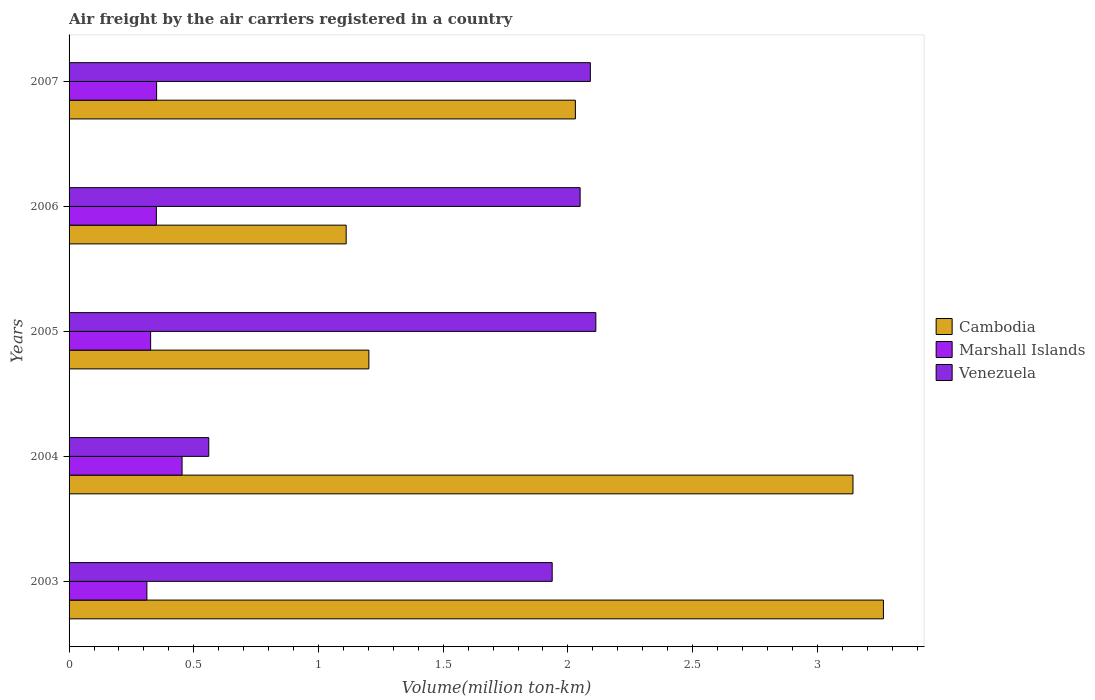How many different coloured bars are there?
Make the answer very short. 3. How many groups of bars are there?
Ensure brevity in your answer.  5. How many bars are there on the 2nd tick from the top?
Give a very brief answer. 3. What is the label of the 3rd group of bars from the top?
Your answer should be very brief. 2005. In how many cases, is the number of bars for a given year not equal to the number of legend labels?
Provide a short and direct response. 0. What is the volume of the air carriers in Marshall Islands in 2003?
Provide a succinct answer. 0.31. Across all years, what is the maximum volume of the air carriers in Cambodia?
Your response must be concise. 3.27. Across all years, what is the minimum volume of the air carriers in Marshall Islands?
Offer a terse response. 0.31. In which year was the volume of the air carriers in Venezuela maximum?
Ensure brevity in your answer.  2005. What is the total volume of the air carriers in Venezuela in the graph?
Offer a terse response. 8.75. What is the difference between the volume of the air carriers in Venezuela in 2003 and that in 2004?
Your response must be concise. 1.38. What is the difference between the volume of the air carriers in Marshall Islands in 2004 and the volume of the air carriers in Venezuela in 2007?
Provide a short and direct response. -1.64. What is the average volume of the air carriers in Venezuela per year?
Give a very brief answer. 1.75. In the year 2006, what is the difference between the volume of the air carriers in Cambodia and volume of the air carriers in Marshall Islands?
Provide a succinct answer. 0.76. What is the ratio of the volume of the air carriers in Marshall Islands in 2003 to that in 2006?
Keep it short and to the point. 0.89. Is the difference between the volume of the air carriers in Cambodia in 2004 and 2007 greater than the difference between the volume of the air carriers in Marshall Islands in 2004 and 2007?
Your answer should be compact. Yes. What is the difference between the highest and the second highest volume of the air carriers in Marshall Islands?
Your response must be concise. 0.1. What is the difference between the highest and the lowest volume of the air carriers in Marshall Islands?
Your answer should be very brief. 0.14. In how many years, is the volume of the air carriers in Venezuela greater than the average volume of the air carriers in Venezuela taken over all years?
Offer a very short reply. 4. What does the 3rd bar from the top in 2004 represents?
Provide a short and direct response. Cambodia. What does the 3rd bar from the bottom in 2007 represents?
Give a very brief answer. Venezuela. Are all the bars in the graph horizontal?
Your answer should be compact. Yes. How many years are there in the graph?
Your answer should be very brief. 5. Does the graph contain any zero values?
Make the answer very short. No. Does the graph contain grids?
Keep it short and to the point. No. Where does the legend appear in the graph?
Keep it short and to the point. Center right. How are the legend labels stacked?
Keep it short and to the point. Vertical. What is the title of the graph?
Offer a terse response. Air freight by the air carriers registered in a country. What is the label or title of the X-axis?
Your answer should be very brief. Volume(million ton-km). What is the Volume(million ton-km) of Cambodia in 2003?
Offer a very short reply. 3.27. What is the Volume(million ton-km) of Marshall Islands in 2003?
Provide a succinct answer. 0.31. What is the Volume(million ton-km) in Venezuela in 2003?
Provide a succinct answer. 1.94. What is the Volume(million ton-km) of Cambodia in 2004?
Provide a short and direct response. 3.14. What is the Volume(million ton-km) in Marshall Islands in 2004?
Ensure brevity in your answer.  0.45. What is the Volume(million ton-km) in Venezuela in 2004?
Provide a short and direct response. 0.56. What is the Volume(million ton-km) of Cambodia in 2005?
Offer a very short reply. 1.2. What is the Volume(million ton-km) in Marshall Islands in 2005?
Offer a terse response. 0.33. What is the Volume(million ton-km) of Venezuela in 2005?
Your answer should be compact. 2.11. What is the Volume(million ton-km) of Cambodia in 2006?
Provide a succinct answer. 1.11. What is the Volume(million ton-km) of Venezuela in 2006?
Your response must be concise. 2.05. What is the Volume(million ton-km) of Cambodia in 2007?
Offer a terse response. 2.03. What is the Volume(million ton-km) in Marshall Islands in 2007?
Ensure brevity in your answer.  0.35. What is the Volume(million ton-km) in Venezuela in 2007?
Offer a terse response. 2.09. Across all years, what is the maximum Volume(million ton-km) in Cambodia?
Provide a short and direct response. 3.27. Across all years, what is the maximum Volume(million ton-km) in Marshall Islands?
Your answer should be very brief. 0.45. Across all years, what is the maximum Volume(million ton-km) in Venezuela?
Your answer should be very brief. 2.11. Across all years, what is the minimum Volume(million ton-km) in Cambodia?
Keep it short and to the point. 1.11. Across all years, what is the minimum Volume(million ton-km) in Marshall Islands?
Provide a short and direct response. 0.31. Across all years, what is the minimum Volume(million ton-km) in Venezuela?
Offer a very short reply. 0.56. What is the total Volume(million ton-km) of Cambodia in the graph?
Offer a very short reply. 10.75. What is the total Volume(million ton-km) of Marshall Islands in the graph?
Provide a short and direct response. 1.79. What is the total Volume(million ton-km) in Venezuela in the graph?
Provide a short and direct response. 8.75. What is the difference between the Volume(million ton-km) in Cambodia in 2003 and that in 2004?
Your response must be concise. 0.12. What is the difference between the Volume(million ton-km) of Marshall Islands in 2003 and that in 2004?
Give a very brief answer. -0.14. What is the difference between the Volume(million ton-km) of Venezuela in 2003 and that in 2004?
Ensure brevity in your answer.  1.38. What is the difference between the Volume(million ton-km) of Cambodia in 2003 and that in 2005?
Offer a very short reply. 2.06. What is the difference between the Volume(million ton-km) of Marshall Islands in 2003 and that in 2005?
Offer a terse response. -0.01. What is the difference between the Volume(million ton-km) of Venezuela in 2003 and that in 2005?
Your answer should be compact. -0.17. What is the difference between the Volume(million ton-km) in Cambodia in 2003 and that in 2006?
Provide a succinct answer. 2.15. What is the difference between the Volume(million ton-km) in Marshall Islands in 2003 and that in 2006?
Provide a short and direct response. -0.04. What is the difference between the Volume(million ton-km) in Venezuela in 2003 and that in 2006?
Your response must be concise. -0.11. What is the difference between the Volume(million ton-km) of Cambodia in 2003 and that in 2007?
Offer a terse response. 1.24. What is the difference between the Volume(million ton-km) of Marshall Islands in 2003 and that in 2007?
Make the answer very short. -0.04. What is the difference between the Volume(million ton-km) of Venezuela in 2003 and that in 2007?
Make the answer very short. -0.15. What is the difference between the Volume(million ton-km) in Cambodia in 2004 and that in 2005?
Ensure brevity in your answer.  1.94. What is the difference between the Volume(million ton-km) of Marshall Islands in 2004 and that in 2005?
Offer a terse response. 0.13. What is the difference between the Volume(million ton-km) of Venezuela in 2004 and that in 2005?
Your answer should be very brief. -1.55. What is the difference between the Volume(million ton-km) of Cambodia in 2004 and that in 2006?
Keep it short and to the point. 2.03. What is the difference between the Volume(million ton-km) of Marshall Islands in 2004 and that in 2006?
Provide a succinct answer. 0.1. What is the difference between the Volume(million ton-km) of Venezuela in 2004 and that in 2006?
Keep it short and to the point. -1.49. What is the difference between the Volume(million ton-km) in Cambodia in 2004 and that in 2007?
Your answer should be very brief. 1.11. What is the difference between the Volume(million ton-km) in Marshall Islands in 2004 and that in 2007?
Offer a terse response. 0.1. What is the difference between the Volume(million ton-km) in Venezuela in 2004 and that in 2007?
Ensure brevity in your answer.  -1.53. What is the difference between the Volume(million ton-km) of Cambodia in 2005 and that in 2006?
Ensure brevity in your answer.  0.09. What is the difference between the Volume(million ton-km) in Marshall Islands in 2005 and that in 2006?
Ensure brevity in your answer.  -0.02. What is the difference between the Volume(million ton-km) of Venezuela in 2005 and that in 2006?
Offer a terse response. 0.06. What is the difference between the Volume(million ton-km) of Cambodia in 2005 and that in 2007?
Your response must be concise. -0.83. What is the difference between the Volume(million ton-km) in Marshall Islands in 2005 and that in 2007?
Give a very brief answer. -0.02. What is the difference between the Volume(million ton-km) of Venezuela in 2005 and that in 2007?
Ensure brevity in your answer.  0.02. What is the difference between the Volume(million ton-km) in Cambodia in 2006 and that in 2007?
Keep it short and to the point. -0.92. What is the difference between the Volume(million ton-km) in Marshall Islands in 2006 and that in 2007?
Offer a terse response. -0. What is the difference between the Volume(million ton-km) of Venezuela in 2006 and that in 2007?
Offer a terse response. -0.04. What is the difference between the Volume(million ton-km) in Cambodia in 2003 and the Volume(million ton-km) in Marshall Islands in 2004?
Offer a terse response. 2.81. What is the difference between the Volume(million ton-km) of Cambodia in 2003 and the Volume(million ton-km) of Venezuela in 2004?
Offer a very short reply. 2.71. What is the difference between the Volume(million ton-km) of Marshall Islands in 2003 and the Volume(million ton-km) of Venezuela in 2004?
Give a very brief answer. -0.25. What is the difference between the Volume(million ton-km) of Cambodia in 2003 and the Volume(million ton-km) of Marshall Islands in 2005?
Provide a short and direct response. 2.94. What is the difference between the Volume(million ton-km) in Cambodia in 2003 and the Volume(million ton-km) in Venezuela in 2005?
Ensure brevity in your answer.  1.15. What is the difference between the Volume(million ton-km) in Marshall Islands in 2003 and the Volume(million ton-km) in Venezuela in 2005?
Your answer should be compact. -1.8. What is the difference between the Volume(million ton-km) in Cambodia in 2003 and the Volume(million ton-km) in Marshall Islands in 2006?
Provide a short and direct response. 2.92. What is the difference between the Volume(million ton-km) in Cambodia in 2003 and the Volume(million ton-km) in Venezuela in 2006?
Provide a succinct answer. 1.22. What is the difference between the Volume(million ton-km) in Marshall Islands in 2003 and the Volume(million ton-km) in Venezuela in 2006?
Your answer should be very brief. -1.74. What is the difference between the Volume(million ton-km) of Cambodia in 2003 and the Volume(million ton-km) of Marshall Islands in 2007?
Your answer should be very brief. 2.91. What is the difference between the Volume(million ton-km) of Cambodia in 2003 and the Volume(million ton-km) of Venezuela in 2007?
Your response must be concise. 1.18. What is the difference between the Volume(million ton-km) of Marshall Islands in 2003 and the Volume(million ton-km) of Venezuela in 2007?
Give a very brief answer. -1.78. What is the difference between the Volume(million ton-km) of Cambodia in 2004 and the Volume(million ton-km) of Marshall Islands in 2005?
Offer a very short reply. 2.82. What is the difference between the Volume(million ton-km) in Cambodia in 2004 and the Volume(million ton-km) in Venezuela in 2005?
Your response must be concise. 1.03. What is the difference between the Volume(million ton-km) of Marshall Islands in 2004 and the Volume(million ton-km) of Venezuela in 2005?
Your answer should be compact. -1.66. What is the difference between the Volume(million ton-km) in Cambodia in 2004 and the Volume(million ton-km) in Marshall Islands in 2006?
Your answer should be compact. 2.79. What is the difference between the Volume(million ton-km) of Cambodia in 2004 and the Volume(million ton-km) of Venezuela in 2006?
Your answer should be very brief. 1.09. What is the difference between the Volume(million ton-km) in Marshall Islands in 2004 and the Volume(million ton-km) in Venezuela in 2006?
Make the answer very short. -1.6. What is the difference between the Volume(million ton-km) of Cambodia in 2004 and the Volume(million ton-km) of Marshall Islands in 2007?
Offer a very short reply. 2.79. What is the difference between the Volume(million ton-km) in Cambodia in 2004 and the Volume(million ton-km) in Venezuela in 2007?
Make the answer very short. 1.05. What is the difference between the Volume(million ton-km) of Marshall Islands in 2004 and the Volume(million ton-km) of Venezuela in 2007?
Your answer should be compact. -1.64. What is the difference between the Volume(million ton-km) of Cambodia in 2005 and the Volume(million ton-km) of Marshall Islands in 2006?
Make the answer very short. 0.85. What is the difference between the Volume(million ton-km) in Cambodia in 2005 and the Volume(million ton-km) in Venezuela in 2006?
Make the answer very short. -0.85. What is the difference between the Volume(million ton-km) in Marshall Islands in 2005 and the Volume(million ton-km) in Venezuela in 2006?
Your response must be concise. -1.72. What is the difference between the Volume(million ton-km) in Cambodia in 2005 and the Volume(million ton-km) in Marshall Islands in 2007?
Give a very brief answer. 0.85. What is the difference between the Volume(million ton-km) of Cambodia in 2005 and the Volume(million ton-km) of Venezuela in 2007?
Provide a succinct answer. -0.89. What is the difference between the Volume(million ton-km) in Marshall Islands in 2005 and the Volume(million ton-km) in Venezuela in 2007?
Your answer should be compact. -1.76. What is the difference between the Volume(million ton-km) of Cambodia in 2006 and the Volume(million ton-km) of Marshall Islands in 2007?
Provide a short and direct response. 0.76. What is the difference between the Volume(million ton-km) in Cambodia in 2006 and the Volume(million ton-km) in Venezuela in 2007?
Provide a short and direct response. -0.98. What is the difference between the Volume(million ton-km) in Marshall Islands in 2006 and the Volume(million ton-km) in Venezuela in 2007?
Your answer should be very brief. -1.74. What is the average Volume(million ton-km) in Cambodia per year?
Provide a succinct answer. 2.15. What is the average Volume(million ton-km) in Marshall Islands per year?
Provide a succinct answer. 0.36. What is the average Volume(million ton-km) of Venezuela per year?
Your answer should be very brief. 1.75. In the year 2003, what is the difference between the Volume(million ton-km) of Cambodia and Volume(million ton-km) of Marshall Islands?
Provide a succinct answer. 2.95. In the year 2003, what is the difference between the Volume(million ton-km) in Cambodia and Volume(million ton-km) in Venezuela?
Your answer should be compact. 1.33. In the year 2003, what is the difference between the Volume(million ton-km) in Marshall Islands and Volume(million ton-km) in Venezuela?
Your response must be concise. -1.62. In the year 2004, what is the difference between the Volume(million ton-km) in Cambodia and Volume(million ton-km) in Marshall Islands?
Ensure brevity in your answer.  2.69. In the year 2004, what is the difference between the Volume(million ton-km) in Cambodia and Volume(million ton-km) in Venezuela?
Your answer should be compact. 2.58. In the year 2004, what is the difference between the Volume(million ton-km) of Marshall Islands and Volume(million ton-km) of Venezuela?
Give a very brief answer. -0.11. In the year 2005, what is the difference between the Volume(million ton-km) of Cambodia and Volume(million ton-km) of Marshall Islands?
Ensure brevity in your answer.  0.88. In the year 2005, what is the difference between the Volume(million ton-km) in Cambodia and Volume(million ton-km) in Venezuela?
Give a very brief answer. -0.91. In the year 2005, what is the difference between the Volume(million ton-km) in Marshall Islands and Volume(million ton-km) in Venezuela?
Your answer should be compact. -1.78. In the year 2006, what is the difference between the Volume(million ton-km) of Cambodia and Volume(million ton-km) of Marshall Islands?
Provide a short and direct response. 0.76. In the year 2006, what is the difference between the Volume(million ton-km) in Cambodia and Volume(million ton-km) in Venezuela?
Offer a very short reply. -0.94. In the year 2006, what is the difference between the Volume(million ton-km) in Marshall Islands and Volume(million ton-km) in Venezuela?
Keep it short and to the point. -1.7. In the year 2007, what is the difference between the Volume(million ton-km) of Cambodia and Volume(million ton-km) of Marshall Islands?
Offer a terse response. 1.68. In the year 2007, what is the difference between the Volume(million ton-km) in Cambodia and Volume(million ton-km) in Venezuela?
Ensure brevity in your answer.  -0.06. In the year 2007, what is the difference between the Volume(million ton-km) in Marshall Islands and Volume(million ton-km) in Venezuela?
Give a very brief answer. -1.74. What is the ratio of the Volume(million ton-km) in Cambodia in 2003 to that in 2004?
Your answer should be very brief. 1.04. What is the ratio of the Volume(million ton-km) in Marshall Islands in 2003 to that in 2004?
Make the answer very short. 0.69. What is the ratio of the Volume(million ton-km) in Venezuela in 2003 to that in 2004?
Your response must be concise. 3.46. What is the ratio of the Volume(million ton-km) of Cambodia in 2003 to that in 2005?
Keep it short and to the point. 2.72. What is the ratio of the Volume(million ton-km) in Marshall Islands in 2003 to that in 2005?
Your response must be concise. 0.95. What is the ratio of the Volume(million ton-km) of Venezuela in 2003 to that in 2005?
Provide a succinct answer. 0.92. What is the ratio of the Volume(million ton-km) of Cambodia in 2003 to that in 2006?
Your answer should be compact. 2.94. What is the ratio of the Volume(million ton-km) of Marshall Islands in 2003 to that in 2006?
Offer a terse response. 0.89. What is the ratio of the Volume(million ton-km) of Venezuela in 2003 to that in 2006?
Your answer should be very brief. 0.95. What is the ratio of the Volume(million ton-km) in Cambodia in 2003 to that in 2007?
Make the answer very short. 1.61. What is the ratio of the Volume(million ton-km) in Marshall Islands in 2003 to that in 2007?
Your response must be concise. 0.89. What is the ratio of the Volume(million ton-km) in Venezuela in 2003 to that in 2007?
Provide a succinct answer. 0.93. What is the ratio of the Volume(million ton-km) in Cambodia in 2004 to that in 2005?
Your response must be concise. 2.61. What is the ratio of the Volume(million ton-km) in Marshall Islands in 2004 to that in 2005?
Offer a very short reply. 1.39. What is the ratio of the Volume(million ton-km) in Venezuela in 2004 to that in 2005?
Provide a short and direct response. 0.27. What is the ratio of the Volume(million ton-km) in Cambodia in 2004 to that in 2006?
Give a very brief answer. 2.83. What is the ratio of the Volume(million ton-km) of Marshall Islands in 2004 to that in 2006?
Provide a short and direct response. 1.29. What is the ratio of the Volume(million ton-km) of Venezuela in 2004 to that in 2006?
Keep it short and to the point. 0.27. What is the ratio of the Volume(million ton-km) in Cambodia in 2004 to that in 2007?
Make the answer very short. 1.55. What is the ratio of the Volume(million ton-km) in Marshall Islands in 2004 to that in 2007?
Ensure brevity in your answer.  1.29. What is the ratio of the Volume(million ton-km) of Venezuela in 2004 to that in 2007?
Make the answer very short. 0.27. What is the ratio of the Volume(million ton-km) in Cambodia in 2005 to that in 2006?
Keep it short and to the point. 1.08. What is the ratio of the Volume(million ton-km) in Marshall Islands in 2005 to that in 2006?
Offer a terse response. 0.93. What is the ratio of the Volume(million ton-km) of Venezuela in 2005 to that in 2006?
Provide a short and direct response. 1.03. What is the ratio of the Volume(million ton-km) of Cambodia in 2005 to that in 2007?
Provide a short and direct response. 0.59. What is the ratio of the Volume(million ton-km) of Marshall Islands in 2005 to that in 2007?
Your answer should be very brief. 0.93. What is the ratio of the Volume(million ton-km) in Venezuela in 2005 to that in 2007?
Offer a terse response. 1.01. What is the ratio of the Volume(million ton-km) in Cambodia in 2006 to that in 2007?
Keep it short and to the point. 0.55. What is the ratio of the Volume(million ton-km) of Marshall Islands in 2006 to that in 2007?
Your answer should be very brief. 1. What is the ratio of the Volume(million ton-km) of Venezuela in 2006 to that in 2007?
Keep it short and to the point. 0.98. What is the difference between the highest and the second highest Volume(million ton-km) in Cambodia?
Your answer should be compact. 0.12. What is the difference between the highest and the second highest Volume(million ton-km) of Marshall Islands?
Offer a terse response. 0.1. What is the difference between the highest and the second highest Volume(million ton-km) of Venezuela?
Provide a succinct answer. 0.02. What is the difference between the highest and the lowest Volume(million ton-km) of Cambodia?
Your response must be concise. 2.15. What is the difference between the highest and the lowest Volume(million ton-km) of Marshall Islands?
Offer a terse response. 0.14. What is the difference between the highest and the lowest Volume(million ton-km) of Venezuela?
Offer a terse response. 1.55. 